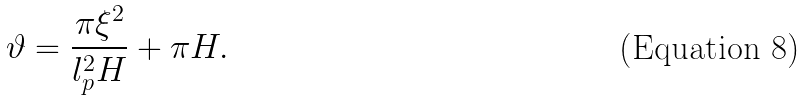Convert formula to latex. <formula><loc_0><loc_0><loc_500><loc_500>\vartheta = \frac { \pi \xi ^ { 2 } } { l _ { p } ^ { 2 } H } + \pi H .</formula> 